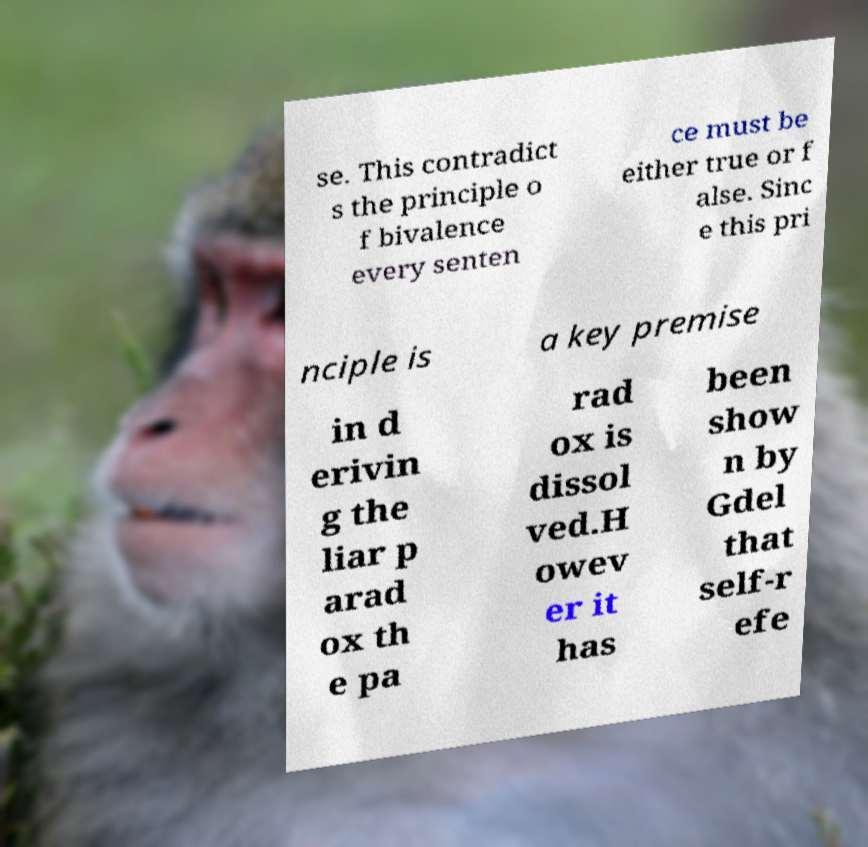For documentation purposes, I need the text within this image transcribed. Could you provide that? se. This contradict s the principle o f bivalence every senten ce must be either true or f alse. Sinc e this pri nciple is a key premise in d erivin g the liar p arad ox th e pa rad ox is dissol ved.H owev er it has been show n by Gdel that self-r efe 